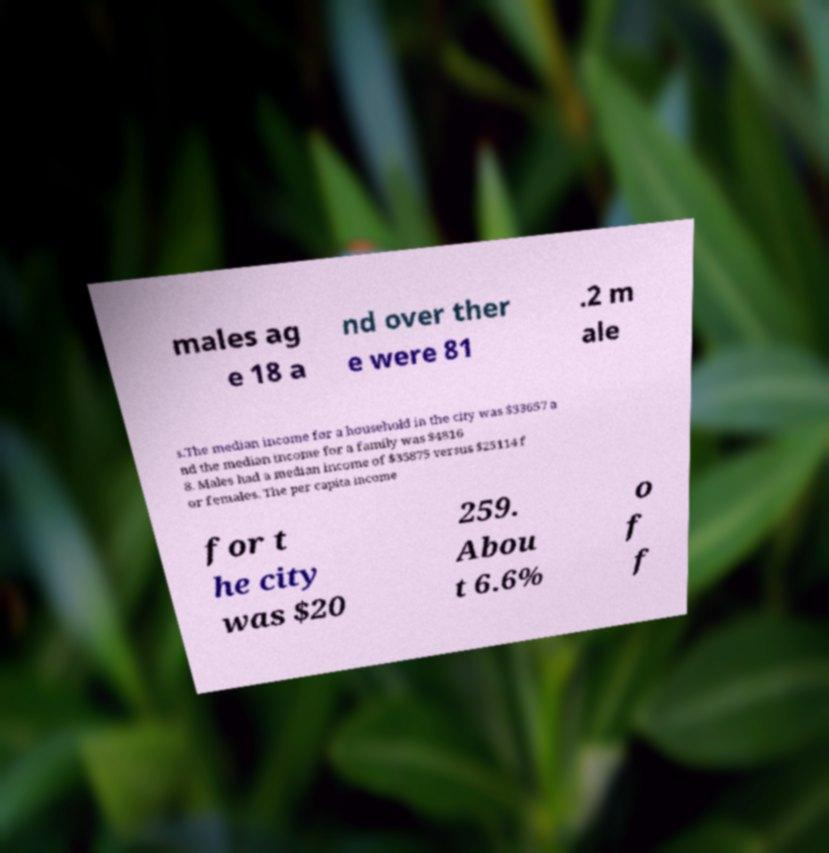Can you accurately transcribe the text from the provided image for me? males ag e 18 a nd over ther e were 81 .2 m ale s.The median income for a household in the city was $33657 a nd the median income for a family was $4816 8. Males had a median income of $35875 versus $25114 f or females. The per capita income for t he city was $20 259. Abou t 6.6% o f f 